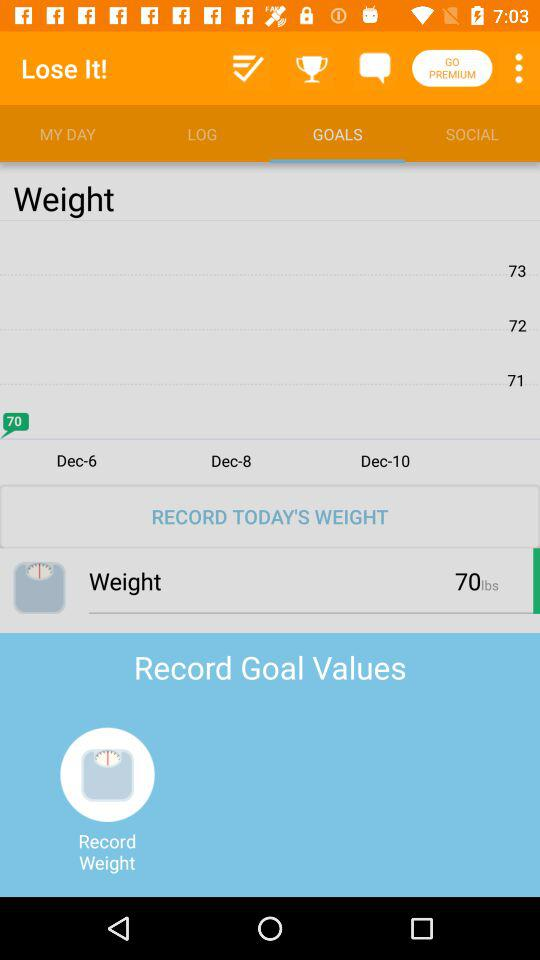What is today's recorded weight? Today's recorded weight is 70 lbs. 